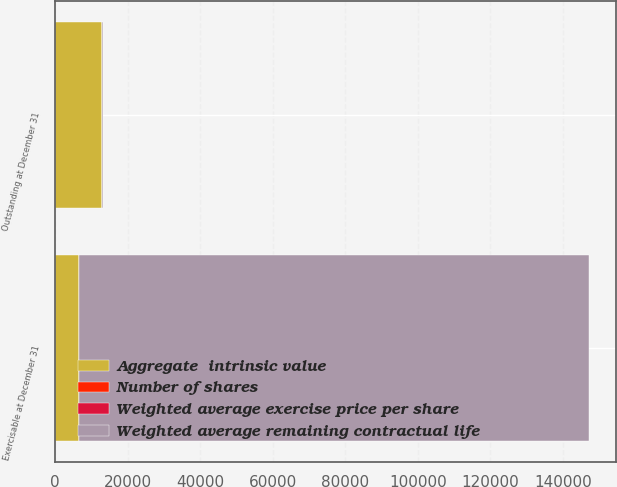Convert chart. <chart><loc_0><loc_0><loc_500><loc_500><stacked_bar_chart><ecel><fcel>Outstanding at December 31<fcel>Exercisable at December 31<nl><fcel>Aggregate  intrinsic value<fcel>12961<fcel>6615<nl><fcel>Number of shares<fcel>44.36<fcel>43.44<nl><fcel>Weighted average exercise price per share<fcel>5.78<fcel>4.3<nl><fcel>Weighted average remaining contractual life<fcel>44.36<fcel>140569<nl></chart> 